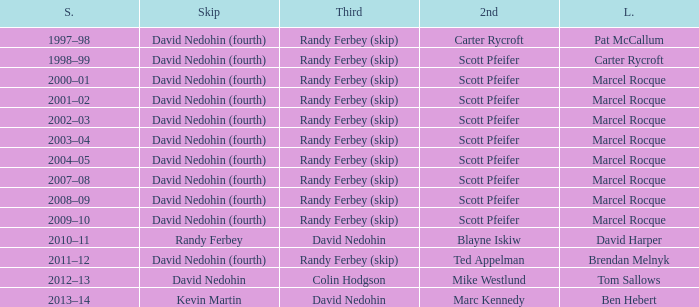Which Second has a Third of david nedohin, and a Lead of ben hebert? Marc Kennedy. 